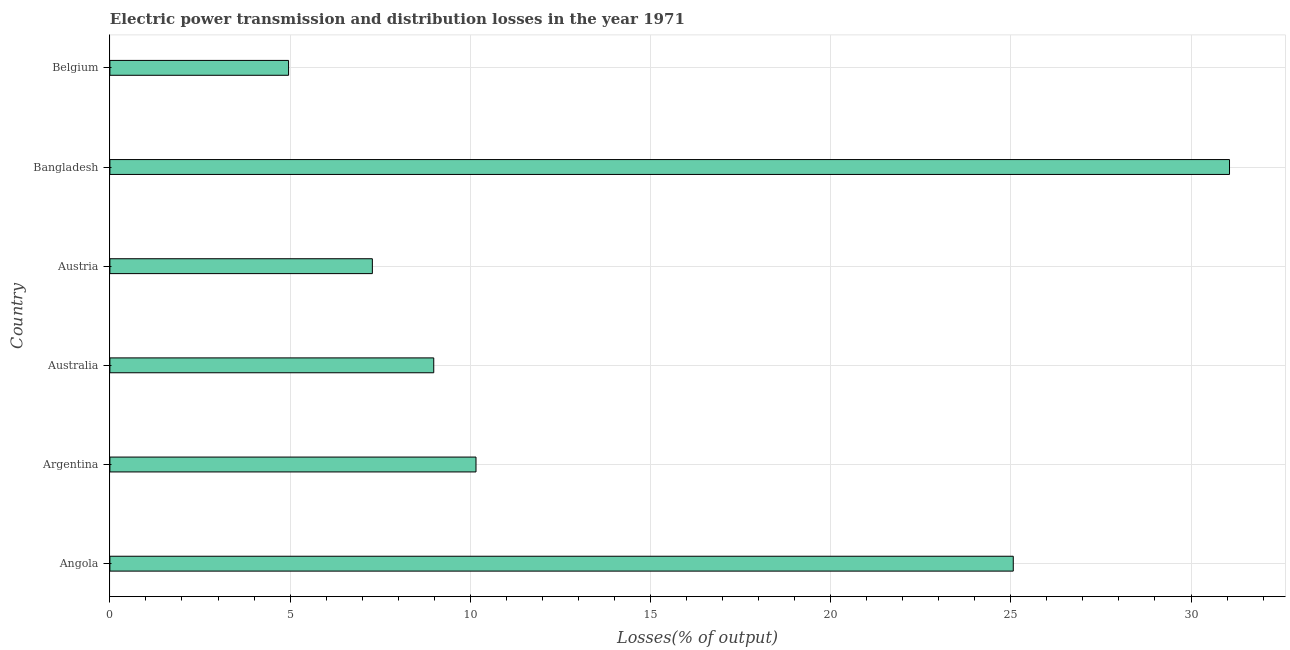Does the graph contain any zero values?
Keep it short and to the point. No. What is the title of the graph?
Your response must be concise. Electric power transmission and distribution losses in the year 1971. What is the label or title of the X-axis?
Provide a succinct answer. Losses(% of output). What is the electric power transmission and distribution losses in Australia?
Offer a very short reply. 8.99. Across all countries, what is the maximum electric power transmission and distribution losses?
Offer a terse response. 31.07. Across all countries, what is the minimum electric power transmission and distribution losses?
Your answer should be compact. 4.96. In which country was the electric power transmission and distribution losses maximum?
Offer a terse response. Bangladesh. What is the sum of the electric power transmission and distribution losses?
Provide a succinct answer. 87.52. What is the difference between the electric power transmission and distribution losses in Australia and Austria?
Make the answer very short. 1.7. What is the average electric power transmission and distribution losses per country?
Provide a short and direct response. 14.59. What is the median electric power transmission and distribution losses?
Ensure brevity in your answer.  9.57. In how many countries, is the electric power transmission and distribution losses greater than 27 %?
Offer a very short reply. 1. What is the ratio of the electric power transmission and distribution losses in Argentina to that in Bangladesh?
Your answer should be compact. 0.33. Is the electric power transmission and distribution losses in Argentina less than that in Belgium?
Offer a very short reply. No. Is the difference between the electric power transmission and distribution losses in Angola and Austria greater than the difference between any two countries?
Provide a succinct answer. No. What is the difference between the highest and the second highest electric power transmission and distribution losses?
Your answer should be compact. 6. What is the difference between the highest and the lowest electric power transmission and distribution losses?
Your answer should be very brief. 26.11. In how many countries, is the electric power transmission and distribution losses greater than the average electric power transmission and distribution losses taken over all countries?
Ensure brevity in your answer.  2. How many bars are there?
Your answer should be very brief. 6. Are all the bars in the graph horizontal?
Your answer should be compact. Yes. What is the difference between two consecutive major ticks on the X-axis?
Keep it short and to the point. 5. What is the Losses(% of output) of Angola?
Your answer should be compact. 25.07. What is the Losses(% of output) in Argentina?
Keep it short and to the point. 10.16. What is the Losses(% of output) in Australia?
Provide a short and direct response. 8.99. What is the Losses(% of output) of Austria?
Provide a succinct answer. 7.28. What is the Losses(% of output) of Bangladesh?
Your answer should be very brief. 31.07. What is the Losses(% of output) of Belgium?
Ensure brevity in your answer.  4.96. What is the difference between the Losses(% of output) in Angola and Argentina?
Ensure brevity in your answer.  14.91. What is the difference between the Losses(% of output) in Angola and Australia?
Ensure brevity in your answer.  16.08. What is the difference between the Losses(% of output) in Angola and Austria?
Offer a very short reply. 17.78. What is the difference between the Losses(% of output) in Angola and Bangladesh?
Keep it short and to the point. -6. What is the difference between the Losses(% of output) in Angola and Belgium?
Offer a very short reply. 20.11. What is the difference between the Losses(% of output) in Argentina and Australia?
Provide a succinct answer. 1.17. What is the difference between the Losses(% of output) in Argentina and Austria?
Offer a very short reply. 2.88. What is the difference between the Losses(% of output) in Argentina and Bangladesh?
Make the answer very short. -20.91. What is the difference between the Losses(% of output) in Argentina and Belgium?
Ensure brevity in your answer.  5.2. What is the difference between the Losses(% of output) in Australia and Austria?
Make the answer very short. 1.7. What is the difference between the Losses(% of output) in Australia and Bangladesh?
Offer a very short reply. -22.08. What is the difference between the Losses(% of output) in Australia and Belgium?
Your response must be concise. 4.03. What is the difference between the Losses(% of output) in Austria and Bangladesh?
Your answer should be compact. -23.78. What is the difference between the Losses(% of output) in Austria and Belgium?
Keep it short and to the point. 2.32. What is the difference between the Losses(% of output) in Bangladesh and Belgium?
Offer a very short reply. 26.11. What is the ratio of the Losses(% of output) in Angola to that in Argentina?
Provide a succinct answer. 2.47. What is the ratio of the Losses(% of output) in Angola to that in Australia?
Your answer should be compact. 2.79. What is the ratio of the Losses(% of output) in Angola to that in Austria?
Offer a very short reply. 3.44. What is the ratio of the Losses(% of output) in Angola to that in Bangladesh?
Provide a succinct answer. 0.81. What is the ratio of the Losses(% of output) in Angola to that in Belgium?
Keep it short and to the point. 5.06. What is the ratio of the Losses(% of output) in Argentina to that in Australia?
Offer a very short reply. 1.13. What is the ratio of the Losses(% of output) in Argentina to that in Austria?
Give a very brief answer. 1.4. What is the ratio of the Losses(% of output) in Argentina to that in Bangladesh?
Provide a succinct answer. 0.33. What is the ratio of the Losses(% of output) in Argentina to that in Belgium?
Your answer should be compact. 2.05. What is the ratio of the Losses(% of output) in Australia to that in Austria?
Ensure brevity in your answer.  1.23. What is the ratio of the Losses(% of output) in Australia to that in Bangladesh?
Provide a succinct answer. 0.29. What is the ratio of the Losses(% of output) in Australia to that in Belgium?
Offer a terse response. 1.81. What is the ratio of the Losses(% of output) in Austria to that in Bangladesh?
Offer a very short reply. 0.23. What is the ratio of the Losses(% of output) in Austria to that in Belgium?
Your answer should be very brief. 1.47. What is the ratio of the Losses(% of output) in Bangladesh to that in Belgium?
Offer a very short reply. 6.27. 